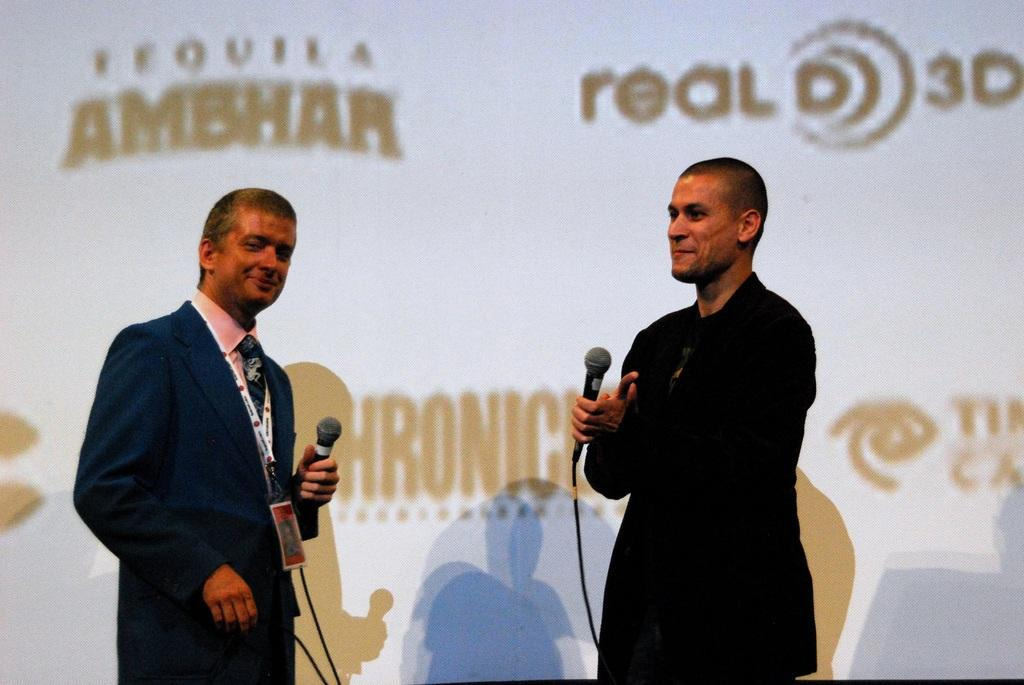How many people are in the image? There are two persons standing in the image. What are the persons holding in their hands? The persons are holding microphones. What is the color of the microphones? The microphones are black in color. What can be seen in the background of the image? There is a white color poster in the background of the image. Are the two persons in the image sisters? There is no information provided about the relationship between the two persons in the image, so we cannot determine if they are sisters. What type of gold object is visible in the image? There is no gold object present in the image. 